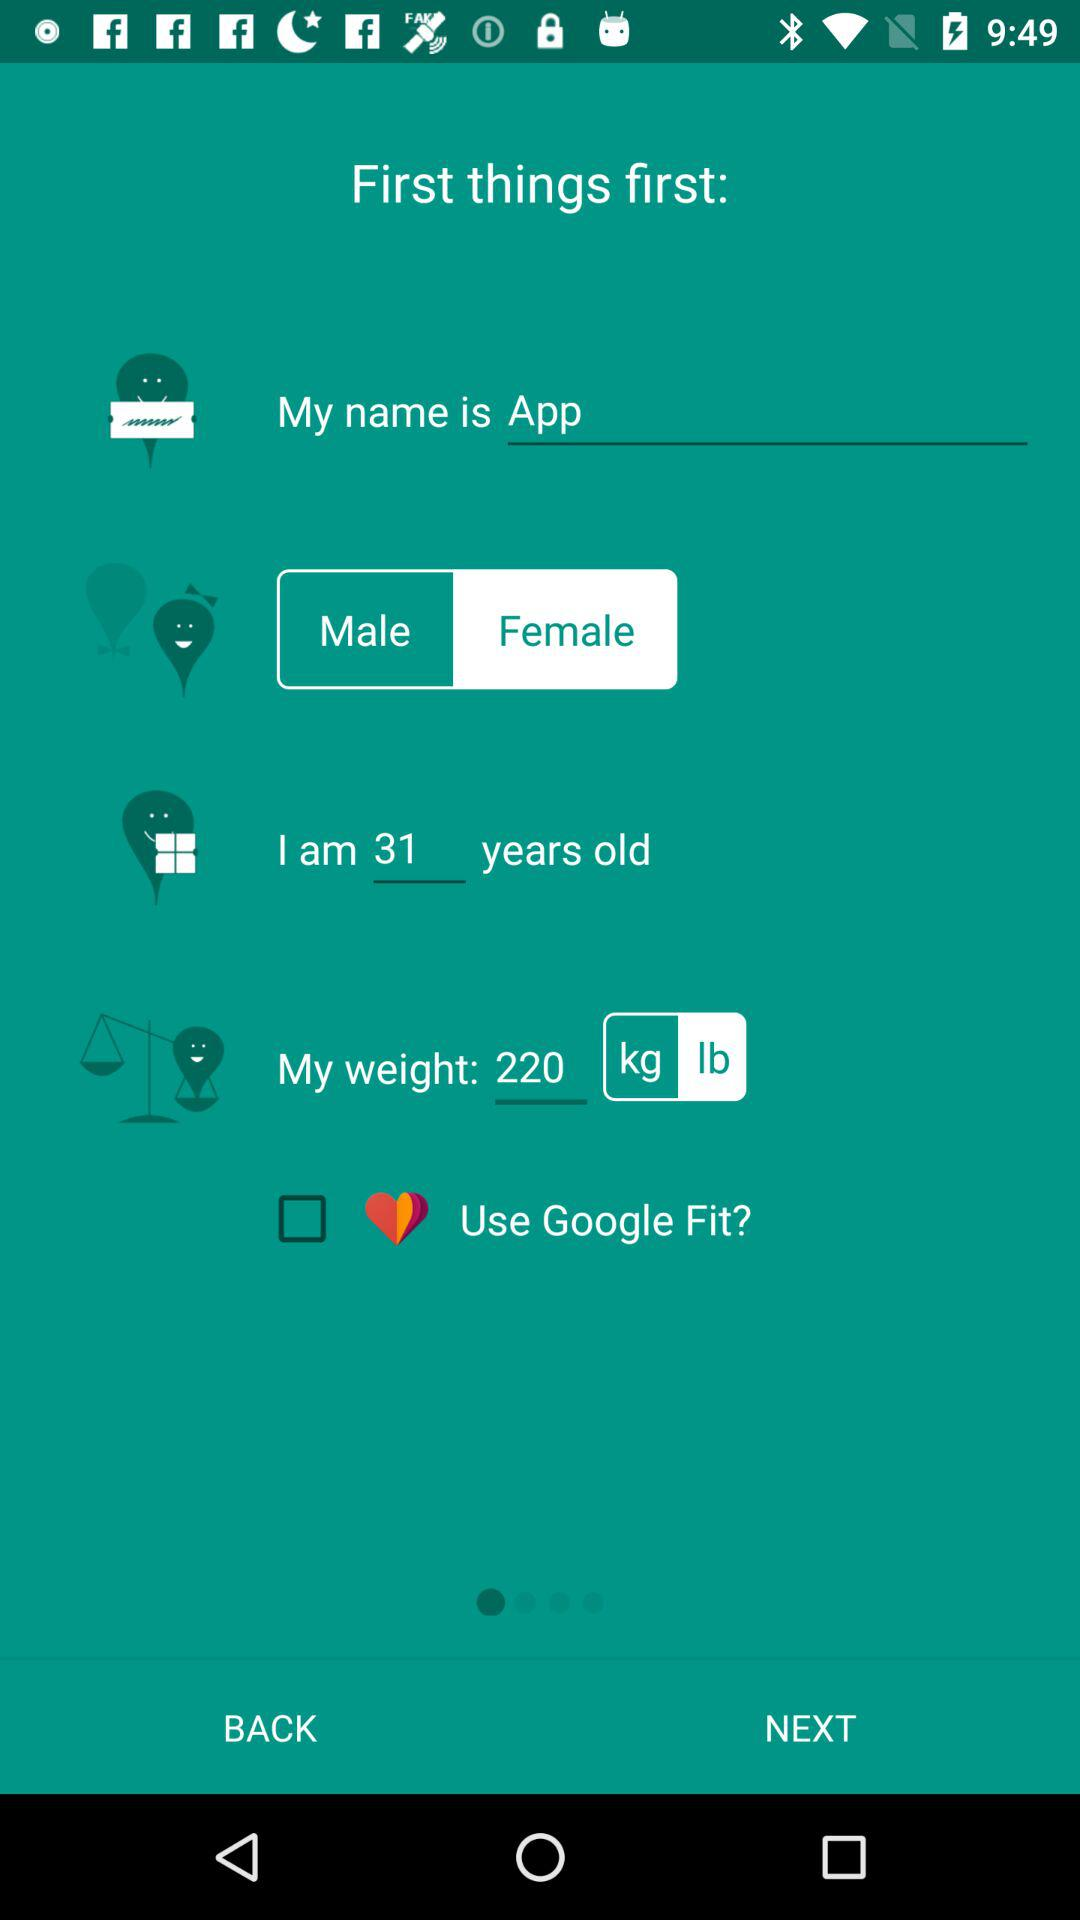Which gender is selected? The selected gender is female. 